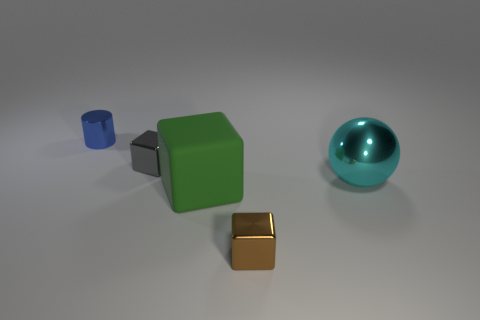Add 2 large cyan metallic cylinders. How many objects exist? 7 Subtract all tiny metal cubes. How many cubes are left? 1 Subtract 1 cylinders. How many cylinders are left? 0 Subtract all green cubes. How many cubes are left? 2 Subtract all cylinders. How many objects are left? 4 Add 4 small yellow matte cubes. How many small yellow matte cubes exist? 4 Subtract 0 red cubes. How many objects are left? 5 Subtract all yellow spheres. Subtract all gray cylinders. How many spheres are left? 1 Subtract all red balls. How many gray cubes are left? 1 Subtract all gray shiny cubes. Subtract all blue shiny cylinders. How many objects are left? 3 